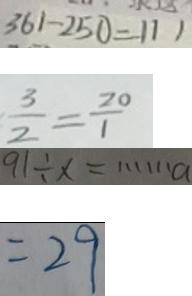Convert formula to latex. <formula><loc_0><loc_0><loc_500><loc_500>3 6 1 - 2 5 0 = 1 1 1 
 \frac { 3 } { 2 } = \frac { 2 0 } { 1 } 
 9 1 \div x = \cdots a 
 = 2 9</formula> 